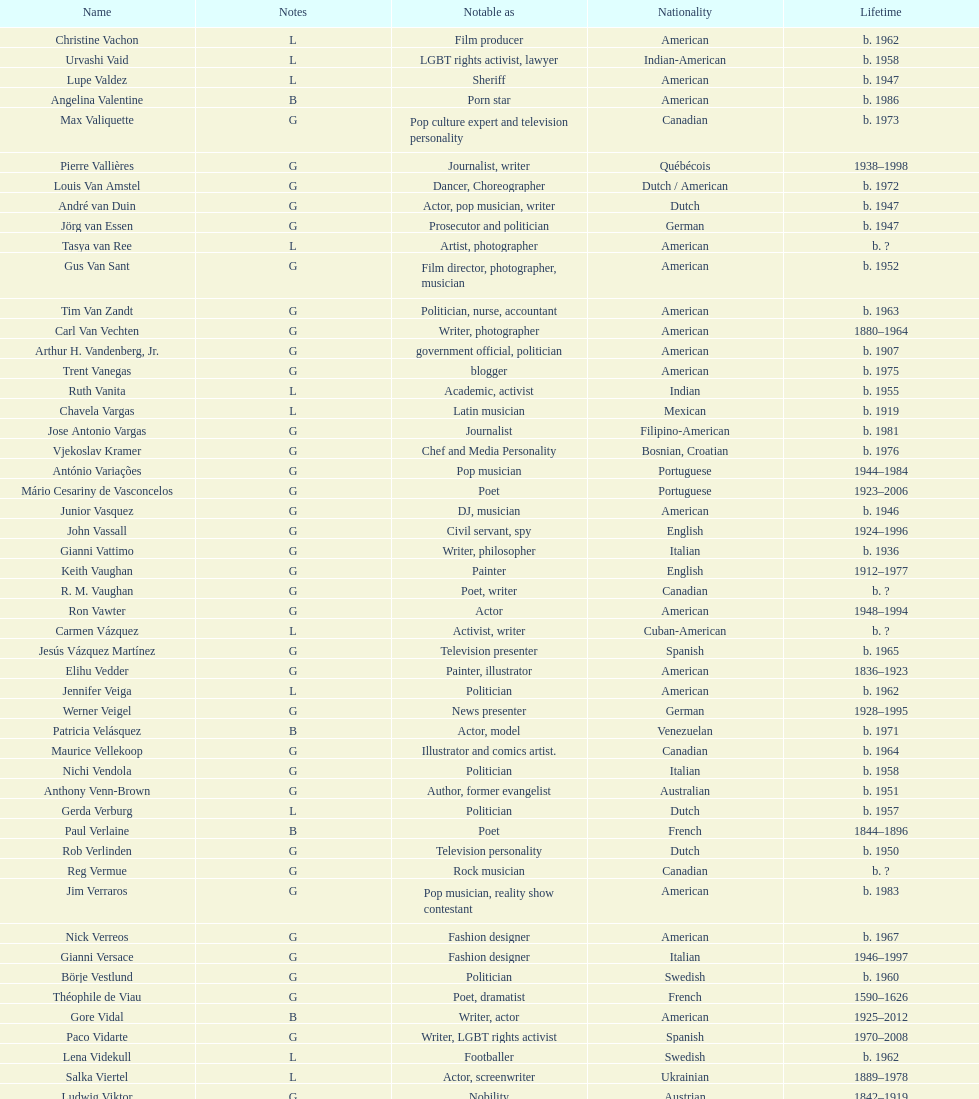What is the difference in year of borth between vachon and vaid? 4 years. 